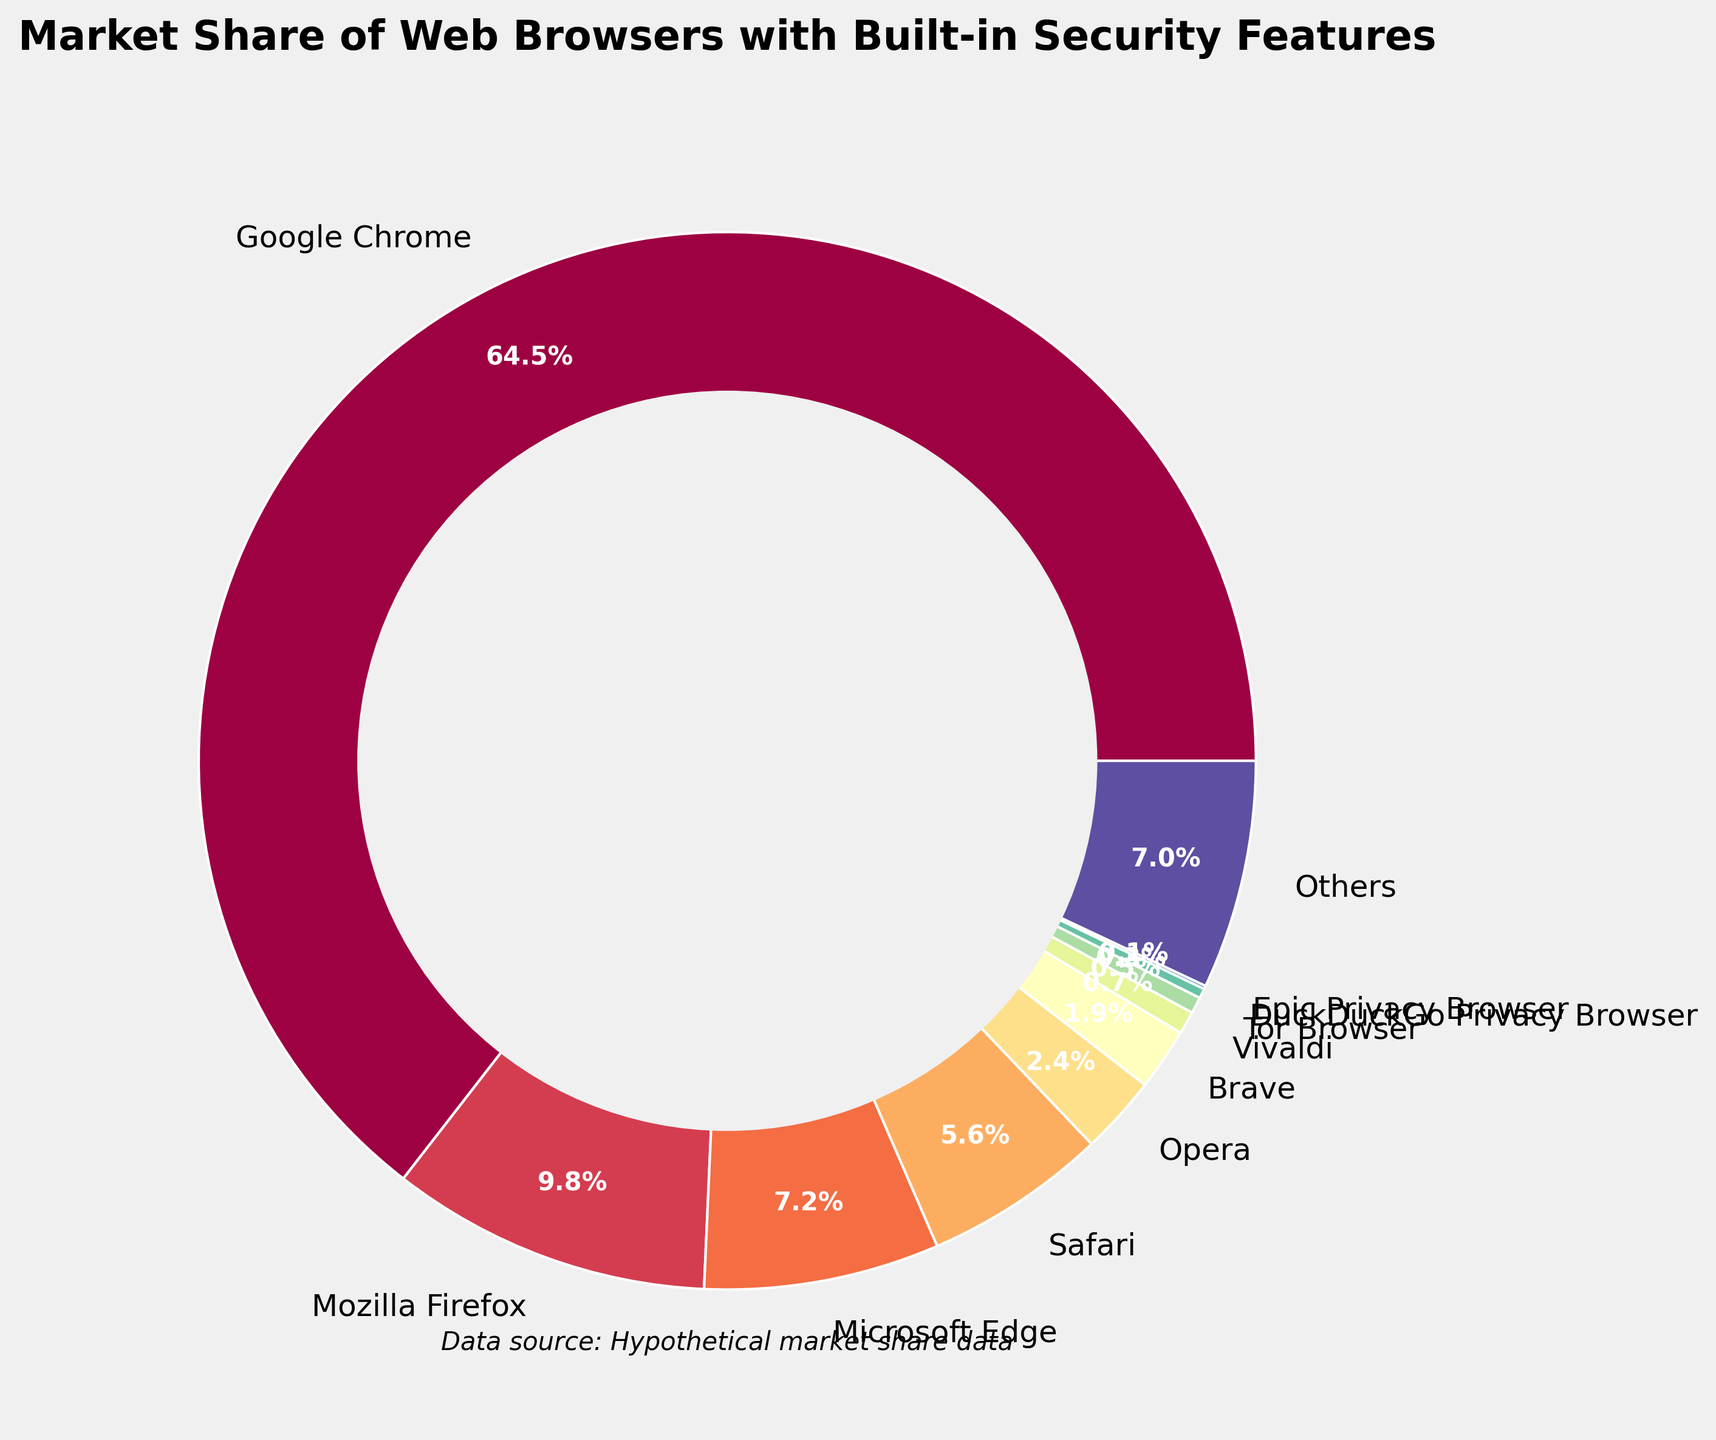What is the browser with the largest market share? By observing the pie chart, the slice corresponding to Google Chrome is the largest, indicating it has the largest market share.
Answer: Google Chrome Which browser has a market share of less than 1% but more than 0.5%? The slices labeled Vivaldi, Tor Browser, DuckDuckGo Privacy Browser, and Epic Privacy Browser represent the smallest shares. Among them, Vivaldi's slice falls between 1% and 0.5%.
Answer: Vivaldi How many percentage points greater is Google Chrome's market share compared to Mozilla Firefox? Google Chrome's market share is 64.5% and Mozilla Firefox's is 9.8%. Subtracting Firefox's share from Chrome's gives 64.5% - 9.8% = 54.7%.
Answer: 54.7 What is the combined market share of all browsers with less than 7% market share? The market shares of Mozilla Firefox (9.8%), Google Chrome (64.5%), and Microsoft Edge (7.2%) are greater than 7%. Summing the shares of the remaining browsers (2.4% + 1.9% + 0.7% + 0.5% + 0.3% + 0.1% + 7.0%) gives the combined share of 12.9%.
Answer: 12.9 Which two browsers have the closest market share values? By comparing the pie chart slices, Microsoft Edge (7.2%) and Safari (5.6%) have a difference of 1.6 percentage points, which is closer than other pairs excluding the exact same browser differences.
Answer: Microsoft Edge and Safari How does the market share of Opera compare to that of Microsoft Edge? Microsoft Edge holds a market share of 7.2%, while Opera holds 2.4%. Therefore, Edge's share is greater than Opera's.
Answer: Microsoft Edge > Opera What is the market share percentage of the browser named Brave? By looking at the labeled slices, Brave's slice shows a market share of 1.9%.
Answer: 1.9 If you sum the market shares of Safari, Opera, and Brave, what is the total market share? Adding the market shares of Safari (5.6%), Opera (2.4%), and Brave (1.9%) results in 5.6% + 2.4% + 1.9% = 9.9%.
Answer: 9.9 